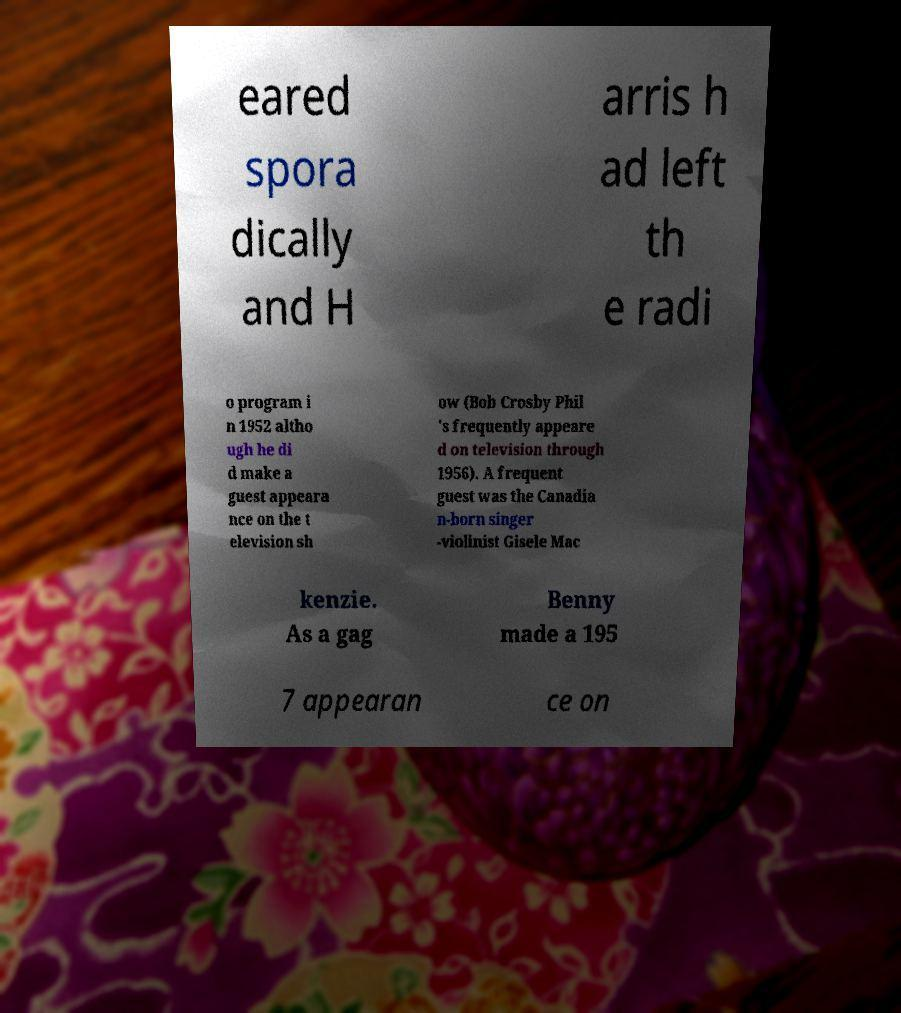What messages or text are displayed in this image? I need them in a readable, typed format. eared spora dically and H arris h ad left th e radi o program i n 1952 altho ugh he di d make a guest appeara nce on the t elevision sh ow (Bob Crosby Phil 's frequently appeare d on television through 1956). A frequent guest was the Canadia n-born singer -violinist Gisele Mac kenzie. As a gag Benny made a 195 7 appearan ce on 